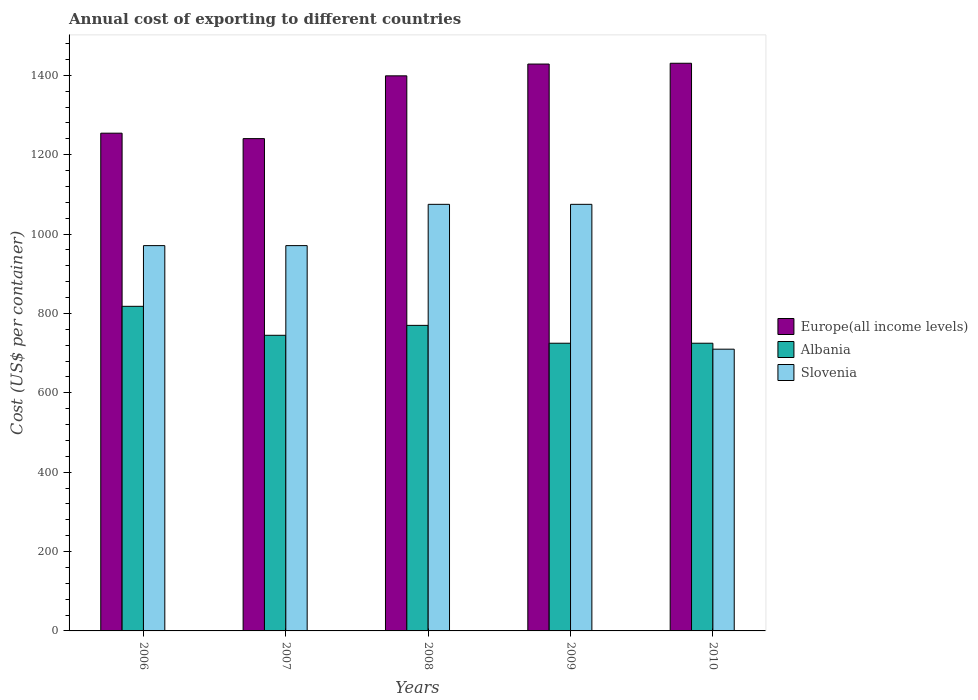How many different coloured bars are there?
Your answer should be very brief. 3. How many groups of bars are there?
Make the answer very short. 5. How many bars are there on the 1st tick from the left?
Give a very brief answer. 3. How many bars are there on the 2nd tick from the right?
Your answer should be compact. 3. What is the label of the 3rd group of bars from the left?
Offer a very short reply. 2008. In how many cases, is the number of bars for a given year not equal to the number of legend labels?
Ensure brevity in your answer.  0. What is the total annual cost of exporting in Albania in 2010?
Ensure brevity in your answer.  725. Across all years, what is the maximum total annual cost of exporting in Slovenia?
Provide a short and direct response. 1075. Across all years, what is the minimum total annual cost of exporting in Slovenia?
Offer a very short reply. 710. What is the total total annual cost of exporting in Europe(all income levels) in the graph?
Offer a very short reply. 6752.85. What is the difference between the total annual cost of exporting in Europe(all income levels) in 2007 and that in 2009?
Offer a very short reply. -187.89. What is the difference between the total annual cost of exporting in Slovenia in 2008 and the total annual cost of exporting in Albania in 2006?
Offer a very short reply. 257. What is the average total annual cost of exporting in Slovenia per year?
Ensure brevity in your answer.  960.4. In the year 2006, what is the difference between the total annual cost of exporting in Europe(all income levels) and total annual cost of exporting in Slovenia?
Your response must be concise. 283.33. What is the ratio of the total annual cost of exporting in Albania in 2006 to that in 2008?
Offer a terse response. 1.06. Is the difference between the total annual cost of exporting in Europe(all income levels) in 2007 and 2010 greater than the difference between the total annual cost of exporting in Slovenia in 2007 and 2010?
Your answer should be very brief. No. What is the difference between the highest and the second highest total annual cost of exporting in Slovenia?
Provide a short and direct response. 0. What is the difference between the highest and the lowest total annual cost of exporting in Albania?
Give a very brief answer. 93. What does the 1st bar from the left in 2010 represents?
Give a very brief answer. Europe(all income levels). What does the 1st bar from the right in 2009 represents?
Give a very brief answer. Slovenia. Are all the bars in the graph horizontal?
Give a very brief answer. No. What is the difference between two consecutive major ticks on the Y-axis?
Keep it short and to the point. 200. Does the graph contain grids?
Offer a very short reply. No. Where does the legend appear in the graph?
Your response must be concise. Center right. How are the legend labels stacked?
Ensure brevity in your answer.  Vertical. What is the title of the graph?
Offer a terse response. Annual cost of exporting to different countries. What is the label or title of the Y-axis?
Offer a very short reply. Cost (US$ per container). What is the Cost (US$ per container) of Europe(all income levels) in 2006?
Provide a short and direct response. 1254.33. What is the Cost (US$ per container) of Albania in 2006?
Keep it short and to the point. 818. What is the Cost (US$ per container) of Slovenia in 2006?
Your answer should be very brief. 971. What is the Cost (US$ per container) of Europe(all income levels) in 2007?
Offer a very short reply. 1240.63. What is the Cost (US$ per container) of Albania in 2007?
Offer a very short reply. 745. What is the Cost (US$ per container) in Slovenia in 2007?
Keep it short and to the point. 971. What is the Cost (US$ per container) in Europe(all income levels) in 2008?
Keep it short and to the point. 1398.83. What is the Cost (US$ per container) of Albania in 2008?
Provide a succinct answer. 770. What is the Cost (US$ per container) in Slovenia in 2008?
Your response must be concise. 1075. What is the Cost (US$ per container) in Europe(all income levels) in 2009?
Provide a short and direct response. 1428.52. What is the Cost (US$ per container) of Albania in 2009?
Offer a terse response. 725. What is the Cost (US$ per container) of Slovenia in 2009?
Offer a very short reply. 1075. What is the Cost (US$ per container) in Europe(all income levels) in 2010?
Your answer should be very brief. 1430.54. What is the Cost (US$ per container) in Albania in 2010?
Give a very brief answer. 725. What is the Cost (US$ per container) of Slovenia in 2010?
Offer a very short reply. 710. Across all years, what is the maximum Cost (US$ per container) in Europe(all income levels)?
Offer a terse response. 1430.54. Across all years, what is the maximum Cost (US$ per container) of Albania?
Offer a terse response. 818. Across all years, what is the maximum Cost (US$ per container) in Slovenia?
Your answer should be very brief. 1075. Across all years, what is the minimum Cost (US$ per container) in Europe(all income levels)?
Offer a very short reply. 1240.63. Across all years, what is the minimum Cost (US$ per container) of Albania?
Offer a very short reply. 725. Across all years, what is the minimum Cost (US$ per container) of Slovenia?
Provide a short and direct response. 710. What is the total Cost (US$ per container) in Europe(all income levels) in the graph?
Your answer should be very brief. 6752.85. What is the total Cost (US$ per container) in Albania in the graph?
Make the answer very short. 3783. What is the total Cost (US$ per container) of Slovenia in the graph?
Ensure brevity in your answer.  4802. What is the difference between the Cost (US$ per container) in Europe(all income levels) in 2006 and that in 2007?
Make the answer very short. 13.7. What is the difference between the Cost (US$ per container) in Slovenia in 2006 and that in 2007?
Provide a succinct answer. 0. What is the difference between the Cost (US$ per container) of Europe(all income levels) in 2006 and that in 2008?
Ensure brevity in your answer.  -144.5. What is the difference between the Cost (US$ per container) in Slovenia in 2006 and that in 2008?
Give a very brief answer. -104. What is the difference between the Cost (US$ per container) of Europe(all income levels) in 2006 and that in 2009?
Provide a short and direct response. -174.19. What is the difference between the Cost (US$ per container) in Albania in 2006 and that in 2009?
Your answer should be compact. 93. What is the difference between the Cost (US$ per container) in Slovenia in 2006 and that in 2009?
Offer a very short reply. -104. What is the difference between the Cost (US$ per container) in Europe(all income levels) in 2006 and that in 2010?
Your response must be concise. -176.22. What is the difference between the Cost (US$ per container) in Albania in 2006 and that in 2010?
Provide a short and direct response. 93. What is the difference between the Cost (US$ per container) in Slovenia in 2006 and that in 2010?
Your answer should be compact. 261. What is the difference between the Cost (US$ per container) of Europe(all income levels) in 2007 and that in 2008?
Offer a terse response. -158.2. What is the difference between the Cost (US$ per container) in Slovenia in 2007 and that in 2008?
Ensure brevity in your answer.  -104. What is the difference between the Cost (US$ per container) in Europe(all income levels) in 2007 and that in 2009?
Give a very brief answer. -187.89. What is the difference between the Cost (US$ per container) of Albania in 2007 and that in 2009?
Offer a very short reply. 20. What is the difference between the Cost (US$ per container) in Slovenia in 2007 and that in 2009?
Provide a succinct answer. -104. What is the difference between the Cost (US$ per container) in Europe(all income levels) in 2007 and that in 2010?
Offer a very short reply. -189.91. What is the difference between the Cost (US$ per container) of Slovenia in 2007 and that in 2010?
Your response must be concise. 261. What is the difference between the Cost (US$ per container) of Europe(all income levels) in 2008 and that in 2009?
Your response must be concise. -29.69. What is the difference between the Cost (US$ per container) of Slovenia in 2008 and that in 2009?
Keep it short and to the point. 0. What is the difference between the Cost (US$ per container) of Europe(all income levels) in 2008 and that in 2010?
Your answer should be compact. -31.71. What is the difference between the Cost (US$ per container) in Albania in 2008 and that in 2010?
Make the answer very short. 45. What is the difference between the Cost (US$ per container) of Slovenia in 2008 and that in 2010?
Your answer should be very brief. 365. What is the difference between the Cost (US$ per container) in Europe(all income levels) in 2009 and that in 2010?
Provide a short and direct response. -2.02. What is the difference between the Cost (US$ per container) of Slovenia in 2009 and that in 2010?
Make the answer very short. 365. What is the difference between the Cost (US$ per container) of Europe(all income levels) in 2006 and the Cost (US$ per container) of Albania in 2007?
Provide a short and direct response. 509.33. What is the difference between the Cost (US$ per container) of Europe(all income levels) in 2006 and the Cost (US$ per container) of Slovenia in 2007?
Offer a terse response. 283.33. What is the difference between the Cost (US$ per container) of Albania in 2006 and the Cost (US$ per container) of Slovenia in 2007?
Offer a very short reply. -153. What is the difference between the Cost (US$ per container) of Europe(all income levels) in 2006 and the Cost (US$ per container) of Albania in 2008?
Your answer should be compact. 484.33. What is the difference between the Cost (US$ per container) of Europe(all income levels) in 2006 and the Cost (US$ per container) of Slovenia in 2008?
Make the answer very short. 179.33. What is the difference between the Cost (US$ per container) in Albania in 2006 and the Cost (US$ per container) in Slovenia in 2008?
Offer a terse response. -257. What is the difference between the Cost (US$ per container) in Europe(all income levels) in 2006 and the Cost (US$ per container) in Albania in 2009?
Your answer should be compact. 529.33. What is the difference between the Cost (US$ per container) in Europe(all income levels) in 2006 and the Cost (US$ per container) in Slovenia in 2009?
Offer a terse response. 179.33. What is the difference between the Cost (US$ per container) in Albania in 2006 and the Cost (US$ per container) in Slovenia in 2009?
Your response must be concise. -257. What is the difference between the Cost (US$ per container) of Europe(all income levels) in 2006 and the Cost (US$ per container) of Albania in 2010?
Ensure brevity in your answer.  529.33. What is the difference between the Cost (US$ per container) in Europe(all income levels) in 2006 and the Cost (US$ per container) in Slovenia in 2010?
Your answer should be compact. 544.33. What is the difference between the Cost (US$ per container) in Albania in 2006 and the Cost (US$ per container) in Slovenia in 2010?
Give a very brief answer. 108. What is the difference between the Cost (US$ per container) in Europe(all income levels) in 2007 and the Cost (US$ per container) in Albania in 2008?
Make the answer very short. 470.63. What is the difference between the Cost (US$ per container) of Europe(all income levels) in 2007 and the Cost (US$ per container) of Slovenia in 2008?
Your response must be concise. 165.63. What is the difference between the Cost (US$ per container) of Albania in 2007 and the Cost (US$ per container) of Slovenia in 2008?
Provide a short and direct response. -330. What is the difference between the Cost (US$ per container) in Europe(all income levels) in 2007 and the Cost (US$ per container) in Albania in 2009?
Offer a terse response. 515.63. What is the difference between the Cost (US$ per container) in Europe(all income levels) in 2007 and the Cost (US$ per container) in Slovenia in 2009?
Keep it short and to the point. 165.63. What is the difference between the Cost (US$ per container) of Albania in 2007 and the Cost (US$ per container) of Slovenia in 2009?
Make the answer very short. -330. What is the difference between the Cost (US$ per container) in Europe(all income levels) in 2007 and the Cost (US$ per container) in Albania in 2010?
Provide a succinct answer. 515.63. What is the difference between the Cost (US$ per container) in Europe(all income levels) in 2007 and the Cost (US$ per container) in Slovenia in 2010?
Keep it short and to the point. 530.63. What is the difference between the Cost (US$ per container) of Albania in 2007 and the Cost (US$ per container) of Slovenia in 2010?
Provide a short and direct response. 35. What is the difference between the Cost (US$ per container) in Europe(all income levels) in 2008 and the Cost (US$ per container) in Albania in 2009?
Give a very brief answer. 673.83. What is the difference between the Cost (US$ per container) of Europe(all income levels) in 2008 and the Cost (US$ per container) of Slovenia in 2009?
Offer a very short reply. 323.83. What is the difference between the Cost (US$ per container) in Albania in 2008 and the Cost (US$ per container) in Slovenia in 2009?
Your answer should be compact. -305. What is the difference between the Cost (US$ per container) in Europe(all income levels) in 2008 and the Cost (US$ per container) in Albania in 2010?
Provide a short and direct response. 673.83. What is the difference between the Cost (US$ per container) in Europe(all income levels) in 2008 and the Cost (US$ per container) in Slovenia in 2010?
Offer a terse response. 688.83. What is the difference between the Cost (US$ per container) of Europe(all income levels) in 2009 and the Cost (US$ per container) of Albania in 2010?
Make the answer very short. 703.52. What is the difference between the Cost (US$ per container) of Europe(all income levels) in 2009 and the Cost (US$ per container) of Slovenia in 2010?
Provide a short and direct response. 718.52. What is the difference between the Cost (US$ per container) of Albania in 2009 and the Cost (US$ per container) of Slovenia in 2010?
Your answer should be compact. 15. What is the average Cost (US$ per container) of Europe(all income levels) per year?
Your answer should be very brief. 1350.57. What is the average Cost (US$ per container) of Albania per year?
Give a very brief answer. 756.6. What is the average Cost (US$ per container) in Slovenia per year?
Offer a very short reply. 960.4. In the year 2006, what is the difference between the Cost (US$ per container) of Europe(all income levels) and Cost (US$ per container) of Albania?
Ensure brevity in your answer.  436.33. In the year 2006, what is the difference between the Cost (US$ per container) of Europe(all income levels) and Cost (US$ per container) of Slovenia?
Keep it short and to the point. 283.33. In the year 2006, what is the difference between the Cost (US$ per container) in Albania and Cost (US$ per container) in Slovenia?
Your answer should be very brief. -153. In the year 2007, what is the difference between the Cost (US$ per container) in Europe(all income levels) and Cost (US$ per container) in Albania?
Your response must be concise. 495.63. In the year 2007, what is the difference between the Cost (US$ per container) of Europe(all income levels) and Cost (US$ per container) of Slovenia?
Offer a terse response. 269.63. In the year 2007, what is the difference between the Cost (US$ per container) in Albania and Cost (US$ per container) in Slovenia?
Your response must be concise. -226. In the year 2008, what is the difference between the Cost (US$ per container) of Europe(all income levels) and Cost (US$ per container) of Albania?
Ensure brevity in your answer.  628.83. In the year 2008, what is the difference between the Cost (US$ per container) in Europe(all income levels) and Cost (US$ per container) in Slovenia?
Offer a terse response. 323.83. In the year 2008, what is the difference between the Cost (US$ per container) of Albania and Cost (US$ per container) of Slovenia?
Make the answer very short. -305. In the year 2009, what is the difference between the Cost (US$ per container) in Europe(all income levels) and Cost (US$ per container) in Albania?
Your response must be concise. 703.52. In the year 2009, what is the difference between the Cost (US$ per container) of Europe(all income levels) and Cost (US$ per container) of Slovenia?
Keep it short and to the point. 353.52. In the year 2009, what is the difference between the Cost (US$ per container) in Albania and Cost (US$ per container) in Slovenia?
Give a very brief answer. -350. In the year 2010, what is the difference between the Cost (US$ per container) of Europe(all income levels) and Cost (US$ per container) of Albania?
Keep it short and to the point. 705.54. In the year 2010, what is the difference between the Cost (US$ per container) in Europe(all income levels) and Cost (US$ per container) in Slovenia?
Your response must be concise. 720.54. What is the ratio of the Cost (US$ per container) in Europe(all income levels) in 2006 to that in 2007?
Ensure brevity in your answer.  1.01. What is the ratio of the Cost (US$ per container) in Albania in 2006 to that in 2007?
Ensure brevity in your answer.  1.1. What is the ratio of the Cost (US$ per container) in Europe(all income levels) in 2006 to that in 2008?
Your answer should be very brief. 0.9. What is the ratio of the Cost (US$ per container) of Albania in 2006 to that in 2008?
Ensure brevity in your answer.  1.06. What is the ratio of the Cost (US$ per container) of Slovenia in 2006 to that in 2008?
Make the answer very short. 0.9. What is the ratio of the Cost (US$ per container) of Europe(all income levels) in 2006 to that in 2009?
Give a very brief answer. 0.88. What is the ratio of the Cost (US$ per container) of Albania in 2006 to that in 2009?
Your answer should be very brief. 1.13. What is the ratio of the Cost (US$ per container) in Slovenia in 2006 to that in 2009?
Make the answer very short. 0.9. What is the ratio of the Cost (US$ per container) in Europe(all income levels) in 2006 to that in 2010?
Give a very brief answer. 0.88. What is the ratio of the Cost (US$ per container) in Albania in 2006 to that in 2010?
Offer a very short reply. 1.13. What is the ratio of the Cost (US$ per container) in Slovenia in 2006 to that in 2010?
Give a very brief answer. 1.37. What is the ratio of the Cost (US$ per container) in Europe(all income levels) in 2007 to that in 2008?
Give a very brief answer. 0.89. What is the ratio of the Cost (US$ per container) in Albania in 2007 to that in 2008?
Your answer should be very brief. 0.97. What is the ratio of the Cost (US$ per container) of Slovenia in 2007 to that in 2008?
Provide a short and direct response. 0.9. What is the ratio of the Cost (US$ per container) of Europe(all income levels) in 2007 to that in 2009?
Provide a succinct answer. 0.87. What is the ratio of the Cost (US$ per container) of Albania in 2007 to that in 2009?
Your answer should be compact. 1.03. What is the ratio of the Cost (US$ per container) of Slovenia in 2007 to that in 2009?
Offer a terse response. 0.9. What is the ratio of the Cost (US$ per container) in Europe(all income levels) in 2007 to that in 2010?
Ensure brevity in your answer.  0.87. What is the ratio of the Cost (US$ per container) of Albania in 2007 to that in 2010?
Make the answer very short. 1.03. What is the ratio of the Cost (US$ per container) of Slovenia in 2007 to that in 2010?
Your answer should be compact. 1.37. What is the ratio of the Cost (US$ per container) of Europe(all income levels) in 2008 to that in 2009?
Provide a short and direct response. 0.98. What is the ratio of the Cost (US$ per container) in Albania in 2008 to that in 2009?
Offer a terse response. 1.06. What is the ratio of the Cost (US$ per container) in Slovenia in 2008 to that in 2009?
Your answer should be compact. 1. What is the ratio of the Cost (US$ per container) of Europe(all income levels) in 2008 to that in 2010?
Provide a short and direct response. 0.98. What is the ratio of the Cost (US$ per container) in Albania in 2008 to that in 2010?
Your answer should be compact. 1.06. What is the ratio of the Cost (US$ per container) of Slovenia in 2008 to that in 2010?
Make the answer very short. 1.51. What is the ratio of the Cost (US$ per container) of Europe(all income levels) in 2009 to that in 2010?
Keep it short and to the point. 1. What is the ratio of the Cost (US$ per container) of Albania in 2009 to that in 2010?
Provide a succinct answer. 1. What is the ratio of the Cost (US$ per container) of Slovenia in 2009 to that in 2010?
Your answer should be compact. 1.51. What is the difference between the highest and the second highest Cost (US$ per container) of Europe(all income levels)?
Keep it short and to the point. 2.02. What is the difference between the highest and the second highest Cost (US$ per container) in Albania?
Keep it short and to the point. 48. What is the difference between the highest and the second highest Cost (US$ per container) in Slovenia?
Your answer should be compact. 0. What is the difference between the highest and the lowest Cost (US$ per container) of Europe(all income levels)?
Give a very brief answer. 189.91. What is the difference between the highest and the lowest Cost (US$ per container) in Albania?
Your answer should be very brief. 93. What is the difference between the highest and the lowest Cost (US$ per container) of Slovenia?
Your answer should be very brief. 365. 